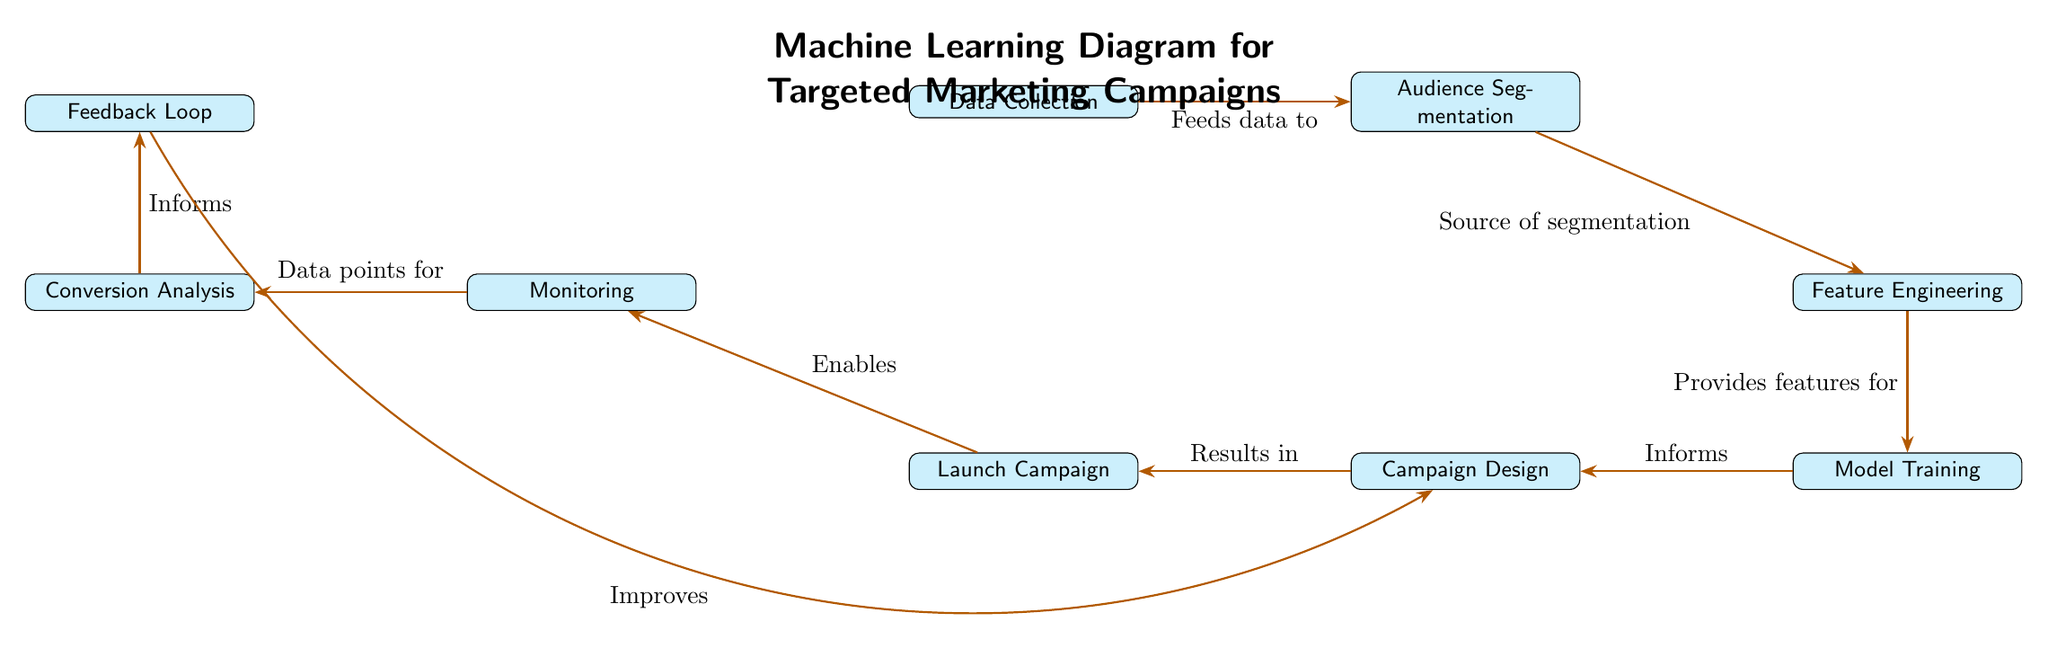What is the first step in the diagram? The diagram starts with the "Data Collection" node, which is the initial process to gather data needed for the marketing campaign.
Answer: Data Collection How many main nodes are there in the diagram? The diagram contains a total of eight main nodes that represent various stages in the targeted marketing campaign process.
Answer: Eight What does the "Audience Segmentation" node feed into? The "Audience Segmentation" node directly connects to the "Feature Engineering" node, signifying that the segmented audiences are processed to extract relevant features.
Answer: Feature Engineering What is the purpose of the "Feedback Loop" in the diagram? The "Feedback Loop" collects insights from the "Conversion Analysis" and sends improvements back to the "Campaign Design," indicating a cyclical enhancement approach.
Answer: Improves Which step comes after "Launch Campaign"? Following the "Launch Campaign," the next step is "Monitoring," where the campaign's effectiveness is evaluated in real-time.
Answer: Monitoring What does the "Monitoring" node provide data for? The "Monitoring" node supplies data points that are essential for performing "Conversion Analysis," helping assess the campaign's success.
Answer: Conversion Analysis Which two nodes are directly connected to the "Model Training" node? "Feature Engineering" provides the necessary features for "Model Training," while "Model Training" informs "Campaign Design," highlighting its role in developing marketing strategies.
Answer: Campaign Design and Feature Engineering What action follows "Conversion Analysis"? After "Conversion Analysis," the insights lead to the "Feedback Loop," which allows for adjustments and improvements based on the analyzed data.
Answer: Feedback Loop What is the visual representation of the process? The diagram visually represents a flow of various nodes interconnected by arrows, each representing a sequential process in targeted marketing campaigns.
Answer: Flow of nodes and arrows 